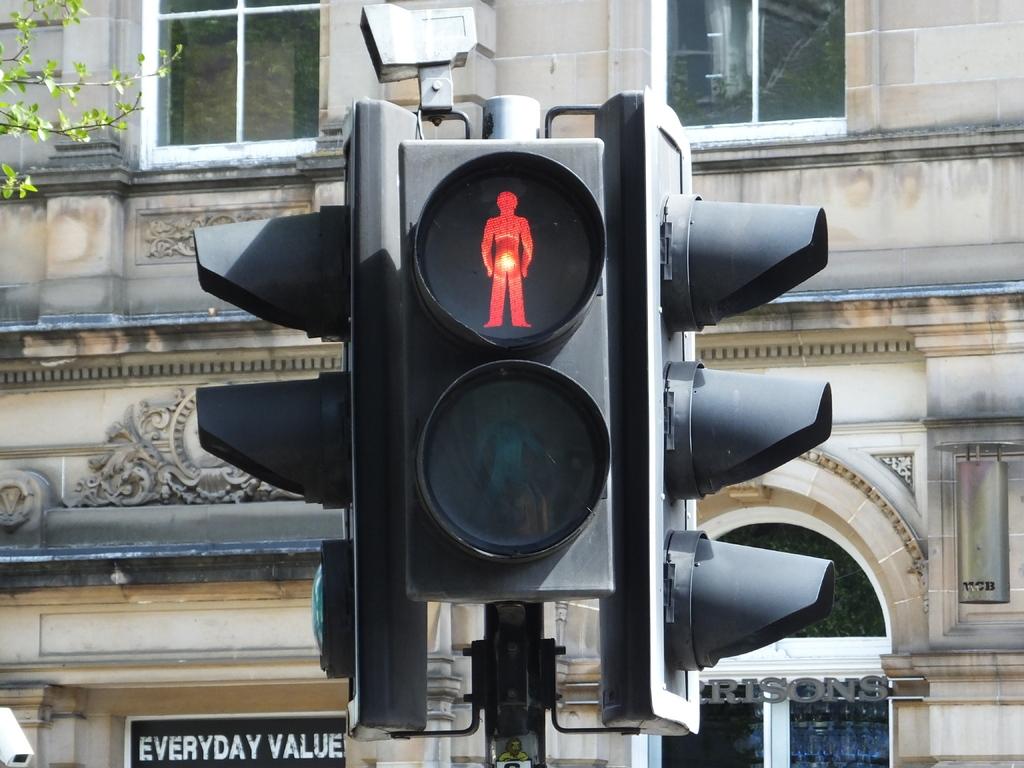What has value?
Provide a short and direct response. Everyday. What store is that?
Provide a succinct answer. Everyday value. 